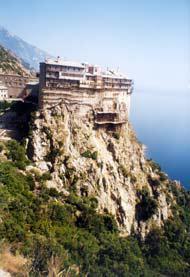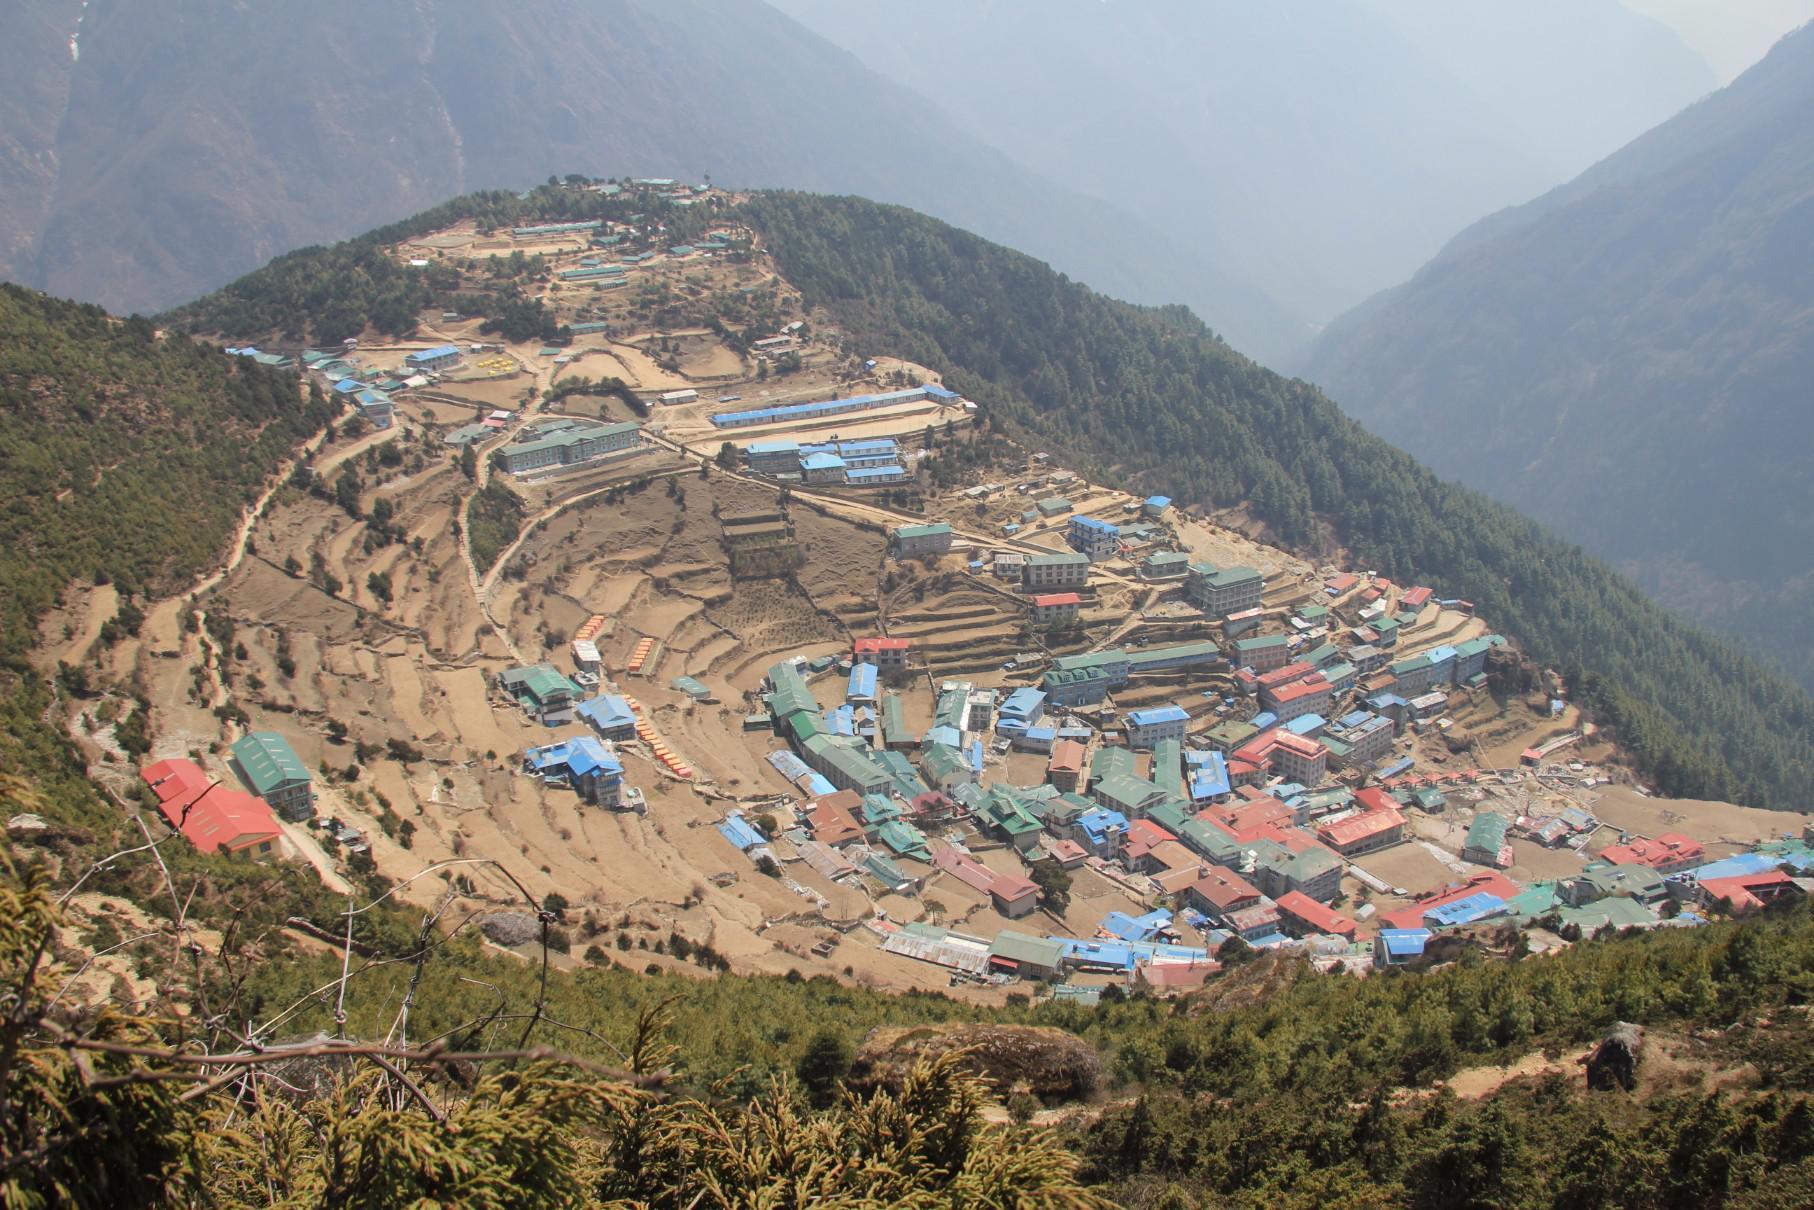The first image is the image on the left, the second image is the image on the right. Examine the images to the left and right. Is the description "In at least one image there is at least ten white house under a yellow house." accurate? Answer yes or no. No. The first image is the image on the left, the second image is the image on the right. For the images displayed, is the sentence "Some roofs are green." factually correct? Answer yes or no. Yes. 